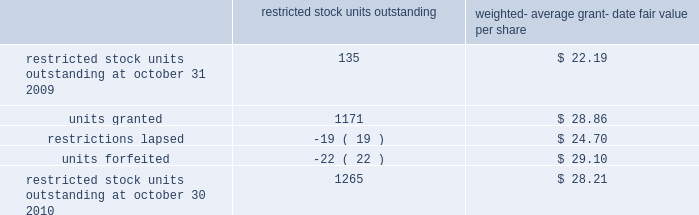Of these options during fiscal 2010 , fiscal 2009 and fiscal 2008 was $ 240.4 million , $ 15.1 million and $ 100.6 mil- lion , respectively .
The total grant-date fair value of stock options that vested during fiscal 2010 , fiscal 2009 and fiscal 2008 was approximately $ 67.2 million , $ 73.6 million and $ 77.6 million , respectively .
Proceeds from stock option exercises pursuant to employee stock plans in the company 2019s statement of cash flows of $ 216.1 million , $ 12.4 million and $ 94.2 million for fiscal 2010 , fiscal 2009 and fiscal 2008 , respectively , are net of the value of shares surrendered by employees in certain limited circumstances to satisfy the exercise price of options , and to satisfy employee tax obligations upon vesting of restricted stock or restricted stock units and in connection with the exercise of stock options granted to the company 2019s employees under the company 2019s equity compensation plans .
The withholding amount is based on the company 2019s minimum statutory withholding requirement .
A summary of the company 2019s restricted stock unit award activity as of october 30 , 2010 and changes during the year then ended is presented below : restricted outstanding weighted- average grant- date fair value per share .
As of october 30 , 2010 there was $ 95 million of total unrecognized compensation cost related to unvested share-based awards comprised of stock options and restricted stock units .
That cost is expected to be recognized over a weighted-average period of 1.4 years .
Common stock repurchase program the company 2019s common stock repurchase program has been in place since august 2004 .
In the aggregate , the board of directors has authorized the company to repurchase $ 4 billion of the company 2019s common stock under the program .
Under the program , the company may repurchase outstanding shares of its common stock from time to time in the open market and through privately negotiated transactions .
Unless terminated earlier by resolution of the company 2019s board of directors , the repurchase program will expire when the company has repurchased all shares authorized under the program .
As of october 30 , 2010 , the company had repurchased a total of approximately 116.0 million shares of its common stock for approximately $ 3948.2 million under this program .
An additional $ 51.8 million remains available for repurchase of shares under the current authorized program .
The repurchased shares are held as authorized but unissued shares of common stock .
Any future common stock repurchases will be dependent upon several factors including the amount of cash available to the company in the united states , and the company 2019s financial performance , outlook and liquidity .
The company also from time to time repurchases shares in settlement of employee tax withholding obligations due upon the vesting of restricted stock or restricted stock units , or in certain limited circumstances to satisfy the exercise price of options granted to the company 2019s employees under the company 2019s equity compensation plans .
Preferred stock the company has 471934 authorized shares of $ 1.00 par value preferred stock , none of which is issued or outstanding .
The board of directors is authorized to fix designations , relative rights , preferences and limitations on the preferred stock at the time of issuance .
Analog devices , inc .
Notes to consolidated financial statements 2014 ( continued ) .
What is the total value of restricted stock units outstanding at october 30 , 2010? 
Computations: (1265 * 28.21)
Answer: 35685.65. 